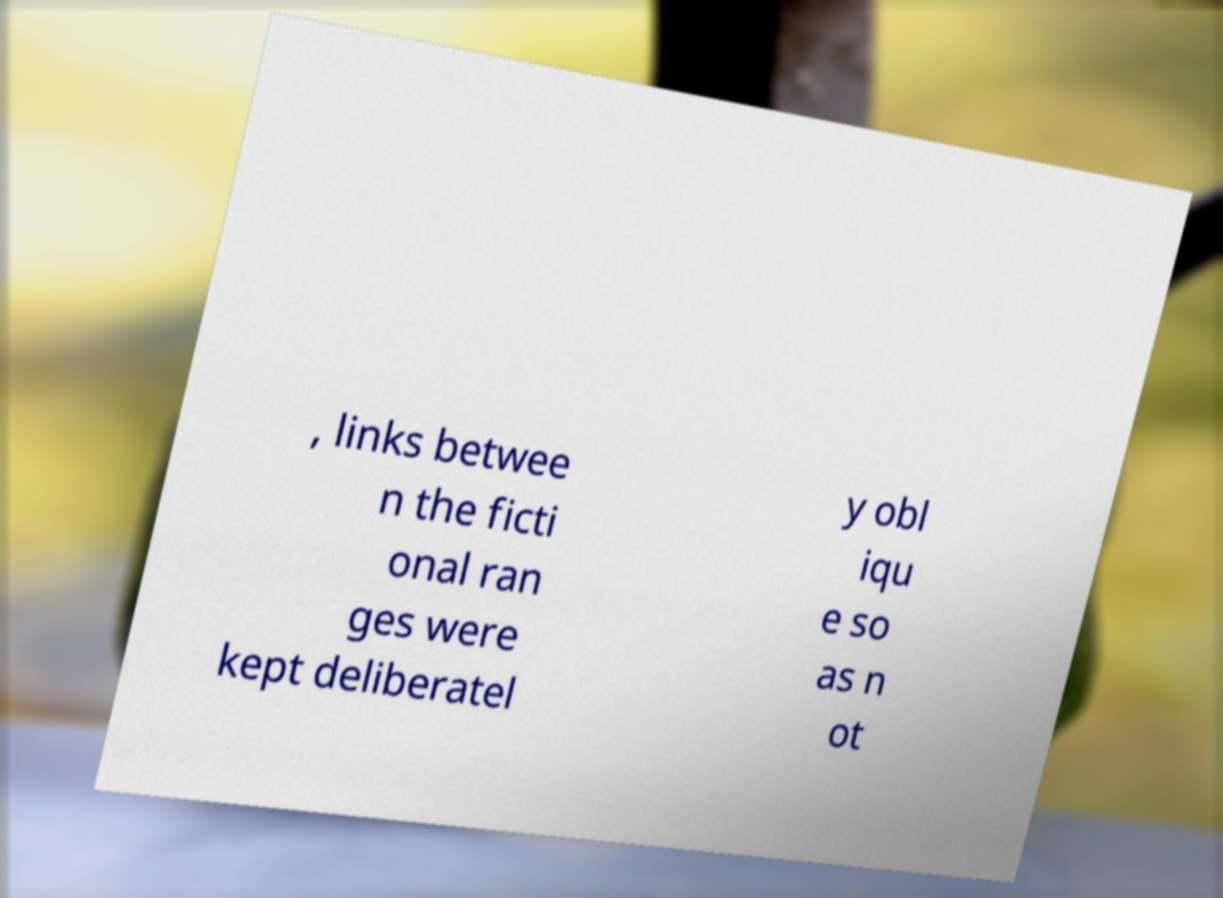Can you read and provide the text displayed in the image?This photo seems to have some interesting text. Can you extract and type it out for me? , links betwee n the ficti onal ran ges were kept deliberatel y obl iqu e so as n ot 